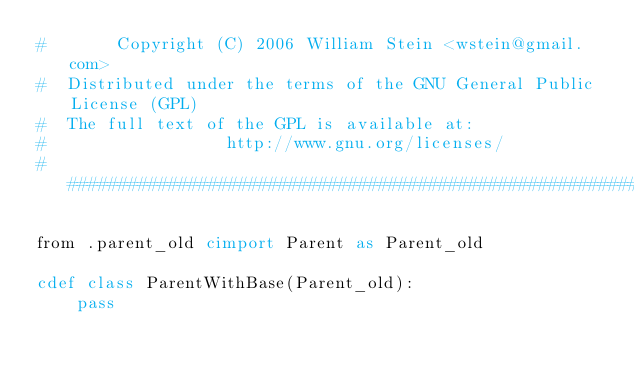<code> <loc_0><loc_0><loc_500><loc_500><_Cython_>#       Copyright (C) 2006 William Stein <wstein@gmail.com>
#  Distributed under the terms of the GNU General Public License (GPL)
#  The full text of the GPL is available at:
#                  http://www.gnu.org/licenses/
###############################################################################

from .parent_old cimport Parent as Parent_old

cdef class ParentWithBase(Parent_old):
    pass
</code> 